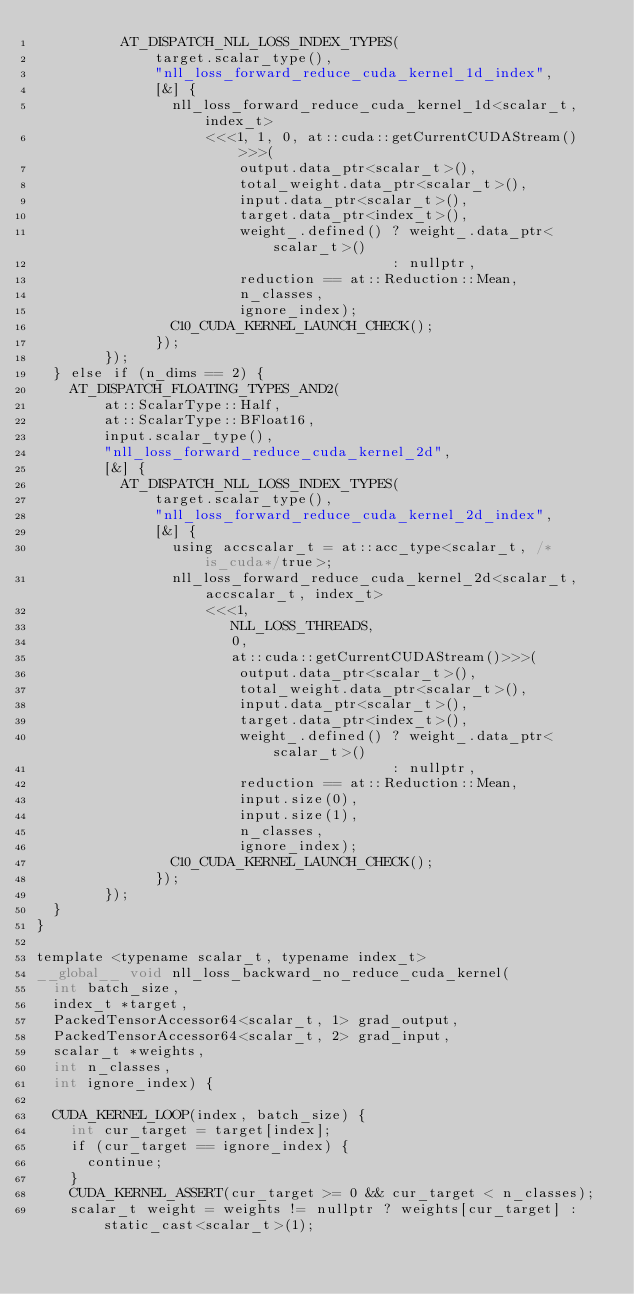Convert code to text. <code><loc_0><loc_0><loc_500><loc_500><_Cuda_>          AT_DISPATCH_NLL_LOSS_INDEX_TYPES(
              target.scalar_type(),
              "nll_loss_forward_reduce_cuda_kernel_1d_index",
              [&] {
                nll_loss_forward_reduce_cuda_kernel_1d<scalar_t, index_t>
                    <<<1, 1, 0, at::cuda::getCurrentCUDAStream()>>>(
                        output.data_ptr<scalar_t>(),
                        total_weight.data_ptr<scalar_t>(),
                        input.data_ptr<scalar_t>(),
                        target.data_ptr<index_t>(),
                        weight_.defined() ? weight_.data_ptr<scalar_t>()
                                          : nullptr,
                        reduction == at::Reduction::Mean,
                        n_classes,
                        ignore_index);
                C10_CUDA_KERNEL_LAUNCH_CHECK();
              });
        });
  } else if (n_dims == 2) {
    AT_DISPATCH_FLOATING_TYPES_AND2(
        at::ScalarType::Half,
        at::ScalarType::BFloat16,
        input.scalar_type(),
        "nll_loss_forward_reduce_cuda_kernel_2d",
        [&] {
          AT_DISPATCH_NLL_LOSS_INDEX_TYPES(
              target.scalar_type(),
              "nll_loss_forward_reduce_cuda_kernel_2d_index",
              [&] {
                using accscalar_t = at::acc_type<scalar_t, /*is_cuda*/true>;
                nll_loss_forward_reduce_cuda_kernel_2d<scalar_t, accscalar_t, index_t>
                    <<<1,
                       NLL_LOSS_THREADS,
                       0,
                       at::cuda::getCurrentCUDAStream()>>>(
                        output.data_ptr<scalar_t>(),
                        total_weight.data_ptr<scalar_t>(),
                        input.data_ptr<scalar_t>(),
                        target.data_ptr<index_t>(),
                        weight_.defined() ? weight_.data_ptr<scalar_t>()
                                          : nullptr,
                        reduction == at::Reduction::Mean,
                        input.size(0),
                        input.size(1),
                        n_classes,
                        ignore_index);
                C10_CUDA_KERNEL_LAUNCH_CHECK();
              });
        });
  }
}

template <typename scalar_t, typename index_t>
__global__ void nll_loss_backward_no_reduce_cuda_kernel(
  int batch_size,
  index_t *target,
  PackedTensorAccessor64<scalar_t, 1> grad_output,
  PackedTensorAccessor64<scalar_t, 2> grad_input,
  scalar_t *weights,
  int n_classes,
  int ignore_index) {

  CUDA_KERNEL_LOOP(index, batch_size) {
    int cur_target = target[index];
    if (cur_target == ignore_index) {
      continue;
    }
    CUDA_KERNEL_ASSERT(cur_target >= 0 && cur_target < n_classes);
    scalar_t weight = weights != nullptr ? weights[cur_target] : static_cast<scalar_t>(1);</code> 